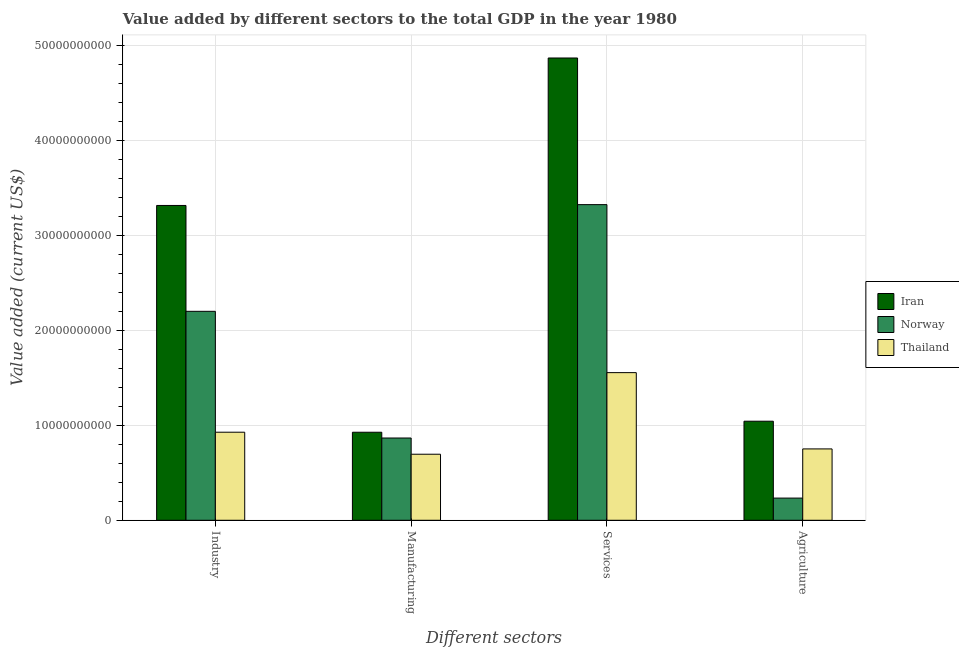How many different coloured bars are there?
Provide a succinct answer. 3. How many groups of bars are there?
Provide a succinct answer. 4. How many bars are there on the 2nd tick from the left?
Offer a very short reply. 3. How many bars are there on the 1st tick from the right?
Your answer should be compact. 3. What is the label of the 1st group of bars from the left?
Your response must be concise. Industry. What is the value added by agricultural sector in Iran?
Make the answer very short. 1.04e+1. Across all countries, what is the maximum value added by agricultural sector?
Provide a succinct answer. 1.04e+1. Across all countries, what is the minimum value added by industrial sector?
Keep it short and to the point. 9.28e+09. In which country was the value added by industrial sector maximum?
Keep it short and to the point. Iran. In which country was the value added by services sector minimum?
Offer a very short reply. Thailand. What is the total value added by services sector in the graph?
Provide a short and direct response. 9.75e+1. What is the difference between the value added by agricultural sector in Thailand and that in Norway?
Your answer should be very brief. 5.18e+09. What is the difference between the value added by agricultural sector in Iran and the value added by manufacturing sector in Thailand?
Give a very brief answer. 3.48e+09. What is the average value added by services sector per country?
Ensure brevity in your answer.  3.25e+1. What is the difference between the value added by agricultural sector and value added by manufacturing sector in Norway?
Offer a very short reply. -6.33e+09. In how many countries, is the value added by services sector greater than 14000000000 US$?
Ensure brevity in your answer.  3. What is the ratio of the value added by agricultural sector in Norway to that in Iran?
Your answer should be very brief. 0.22. Is the difference between the value added by services sector in Iran and Norway greater than the difference between the value added by industrial sector in Iran and Norway?
Offer a terse response. Yes. What is the difference between the highest and the second highest value added by industrial sector?
Provide a short and direct response. 1.12e+1. What is the difference between the highest and the lowest value added by agricultural sector?
Your response must be concise. 8.10e+09. Is the sum of the value added by agricultural sector in Thailand and Iran greater than the maximum value added by industrial sector across all countries?
Your answer should be compact. No. What does the 3rd bar from the left in Manufacturing represents?
Your response must be concise. Thailand. What does the 2nd bar from the right in Industry represents?
Offer a terse response. Norway. Is it the case that in every country, the sum of the value added by industrial sector and value added by manufacturing sector is greater than the value added by services sector?
Your answer should be very brief. No. How many bars are there?
Provide a succinct answer. 12. Are the values on the major ticks of Y-axis written in scientific E-notation?
Provide a short and direct response. No. Does the graph contain any zero values?
Ensure brevity in your answer.  No. Does the graph contain grids?
Keep it short and to the point. Yes. How many legend labels are there?
Your response must be concise. 3. What is the title of the graph?
Your answer should be compact. Value added by different sectors to the total GDP in the year 1980. Does "Bolivia" appear as one of the legend labels in the graph?
Your answer should be very brief. No. What is the label or title of the X-axis?
Make the answer very short. Different sectors. What is the label or title of the Y-axis?
Offer a terse response. Value added (current US$). What is the Value added (current US$) in Iran in Industry?
Your answer should be compact. 3.32e+1. What is the Value added (current US$) of Norway in Industry?
Your answer should be compact. 2.20e+1. What is the Value added (current US$) in Thailand in Industry?
Provide a succinct answer. 9.28e+09. What is the Value added (current US$) of Iran in Manufacturing?
Give a very brief answer. 9.27e+09. What is the Value added (current US$) in Norway in Manufacturing?
Offer a terse response. 8.67e+09. What is the Value added (current US$) of Thailand in Manufacturing?
Provide a short and direct response. 6.96e+09. What is the Value added (current US$) in Iran in Services?
Provide a short and direct response. 4.87e+1. What is the Value added (current US$) in Norway in Services?
Offer a terse response. 3.33e+1. What is the Value added (current US$) of Thailand in Services?
Your response must be concise. 1.56e+1. What is the Value added (current US$) in Iran in Agriculture?
Your answer should be very brief. 1.04e+1. What is the Value added (current US$) of Norway in Agriculture?
Offer a terse response. 2.34e+09. What is the Value added (current US$) in Thailand in Agriculture?
Keep it short and to the point. 7.52e+09. Across all Different sectors, what is the maximum Value added (current US$) of Iran?
Give a very brief answer. 4.87e+1. Across all Different sectors, what is the maximum Value added (current US$) of Norway?
Keep it short and to the point. 3.33e+1. Across all Different sectors, what is the maximum Value added (current US$) in Thailand?
Provide a succinct answer. 1.56e+1. Across all Different sectors, what is the minimum Value added (current US$) in Iran?
Make the answer very short. 9.27e+09. Across all Different sectors, what is the minimum Value added (current US$) in Norway?
Your answer should be very brief. 2.34e+09. Across all Different sectors, what is the minimum Value added (current US$) of Thailand?
Make the answer very short. 6.96e+09. What is the total Value added (current US$) in Iran in the graph?
Give a very brief answer. 1.02e+11. What is the total Value added (current US$) in Norway in the graph?
Your response must be concise. 6.63e+1. What is the total Value added (current US$) of Thailand in the graph?
Provide a short and direct response. 3.93e+1. What is the difference between the Value added (current US$) of Iran in Industry and that in Manufacturing?
Keep it short and to the point. 2.39e+1. What is the difference between the Value added (current US$) in Norway in Industry and that in Manufacturing?
Ensure brevity in your answer.  1.33e+1. What is the difference between the Value added (current US$) of Thailand in Industry and that in Manufacturing?
Ensure brevity in your answer.  2.32e+09. What is the difference between the Value added (current US$) of Iran in Industry and that in Services?
Ensure brevity in your answer.  -1.55e+1. What is the difference between the Value added (current US$) of Norway in Industry and that in Services?
Ensure brevity in your answer.  -1.12e+1. What is the difference between the Value added (current US$) in Thailand in Industry and that in Services?
Make the answer very short. -6.28e+09. What is the difference between the Value added (current US$) in Iran in Industry and that in Agriculture?
Your response must be concise. 2.27e+1. What is the difference between the Value added (current US$) in Norway in Industry and that in Agriculture?
Keep it short and to the point. 1.97e+1. What is the difference between the Value added (current US$) of Thailand in Industry and that in Agriculture?
Keep it short and to the point. 1.76e+09. What is the difference between the Value added (current US$) in Iran in Manufacturing and that in Services?
Ensure brevity in your answer.  -3.94e+1. What is the difference between the Value added (current US$) of Norway in Manufacturing and that in Services?
Provide a short and direct response. -2.46e+1. What is the difference between the Value added (current US$) of Thailand in Manufacturing and that in Services?
Your response must be concise. -8.60e+09. What is the difference between the Value added (current US$) of Iran in Manufacturing and that in Agriculture?
Make the answer very short. -1.16e+09. What is the difference between the Value added (current US$) of Norway in Manufacturing and that in Agriculture?
Your answer should be compact. 6.33e+09. What is the difference between the Value added (current US$) of Thailand in Manufacturing and that in Agriculture?
Your answer should be very brief. -5.59e+08. What is the difference between the Value added (current US$) of Iran in Services and that in Agriculture?
Your response must be concise. 3.83e+1. What is the difference between the Value added (current US$) of Norway in Services and that in Agriculture?
Make the answer very short. 3.09e+1. What is the difference between the Value added (current US$) of Thailand in Services and that in Agriculture?
Offer a terse response. 8.04e+09. What is the difference between the Value added (current US$) in Iran in Industry and the Value added (current US$) in Norway in Manufacturing?
Make the answer very short. 2.45e+1. What is the difference between the Value added (current US$) of Iran in Industry and the Value added (current US$) of Thailand in Manufacturing?
Your answer should be compact. 2.62e+1. What is the difference between the Value added (current US$) of Norway in Industry and the Value added (current US$) of Thailand in Manufacturing?
Provide a short and direct response. 1.51e+1. What is the difference between the Value added (current US$) of Iran in Industry and the Value added (current US$) of Norway in Services?
Keep it short and to the point. -8.79e+07. What is the difference between the Value added (current US$) in Iran in Industry and the Value added (current US$) in Thailand in Services?
Make the answer very short. 1.76e+1. What is the difference between the Value added (current US$) of Norway in Industry and the Value added (current US$) of Thailand in Services?
Offer a terse response. 6.46e+09. What is the difference between the Value added (current US$) in Iran in Industry and the Value added (current US$) in Norway in Agriculture?
Provide a short and direct response. 3.08e+1. What is the difference between the Value added (current US$) of Iran in Industry and the Value added (current US$) of Thailand in Agriculture?
Your response must be concise. 2.57e+1. What is the difference between the Value added (current US$) in Norway in Industry and the Value added (current US$) in Thailand in Agriculture?
Provide a short and direct response. 1.45e+1. What is the difference between the Value added (current US$) in Iran in Manufacturing and the Value added (current US$) in Norway in Services?
Keep it short and to the point. -2.40e+1. What is the difference between the Value added (current US$) in Iran in Manufacturing and the Value added (current US$) in Thailand in Services?
Make the answer very short. -6.28e+09. What is the difference between the Value added (current US$) of Norway in Manufacturing and the Value added (current US$) of Thailand in Services?
Offer a very short reply. -6.89e+09. What is the difference between the Value added (current US$) of Iran in Manufacturing and the Value added (current US$) of Norway in Agriculture?
Your response must be concise. 6.94e+09. What is the difference between the Value added (current US$) of Iran in Manufacturing and the Value added (current US$) of Thailand in Agriculture?
Ensure brevity in your answer.  1.76e+09. What is the difference between the Value added (current US$) in Norway in Manufacturing and the Value added (current US$) in Thailand in Agriculture?
Your answer should be very brief. 1.15e+09. What is the difference between the Value added (current US$) of Iran in Services and the Value added (current US$) of Norway in Agriculture?
Give a very brief answer. 4.64e+1. What is the difference between the Value added (current US$) of Iran in Services and the Value added (current US$) of Thailand in Agriculture?
Give a very brief answer. 4.12e+1. What is the difference between the Value added (current US$) in Norway in Services and the Value added (current US$) in Thailand in Agriculture?
Make the answer very short. 2.57e+1. What is the average Value added (current US$) in Iran per Different sectors?
Offer a very short reply. 2.54e+1. What is the average Value added (current US$) of Norway per Different sectors?
Ensure brevity in your answer.  1.66e+1. What is the average Value added (current US$) in Thailand per Different sectors?
Offer a terse response. 9.83e+09. What is the difference between the Value added (current US$) in Iran and Value added (current US$) in Norway in Industry?
Your answer should be very brief. 1.12e+1. What is the difference between the Value added (current US$) in Iran and Value added (current US$) in Thailand in Industry?
Make the answer very short. 2.39e+1. What is the difference between the Value added (current US$) in Norway and Value added (current US$) in Thailand in Industry?
Provide a short and direct response. 1.27e+1. What is the difference between the Value added (current US$) in Iran and Value added (current US$) in Norway in Manufacturing?
Make the answer very short. 6.06e+08. What is the difference between the Value added (current US$) of Iran and Value added (current US$) of Thailand in Manufacturing?
Keep it short and to the point. 2.32e+09. What is the difference between the Value added (current US$) of Norway and Value added (current US$) of Thailand in Manufacturing?
Your response must be concise. 1.71e+09. What is the difference between the Value added (current US$) of Iran and Value added (current US$) of Norway in Services?
Offer a terse response. 1.55e+1. What is the difference between the Value added (current US$) of Iran and Value added (current US$) of Thailand in Services?
Offer a terse response. 3.32e+1. What is the difference between the Value added (current US$) of Norway and Value added (current US$) of Thailand in Services?
Provide a succinct answer. 1.77e+1. What is the difference between the Value added (current US$) in Iran and Value added (current US$) in Norway in Agriculture?
Offer a terse response. 8.10e+09. What is the difference between the Value added (current US$) in Iran and Value added (current US$) in Thailand in Agriculture?
Provide a short and direct response. 2.92e+09. What is the difference between the Value added (current US$) in Norway and Value added (current US$) in Thailand in Agriculture?
Keep it short and to the point. -5.18e+09. What is the ratio of the Value added (current US$) of Iran in Industry to that in Manufacturing?
Your answer should be very brief. 3.58. What is the ratio of the Value added (current US$) of Norway in Industry to that in Manufacturing?
Offer a very short reply. 2.54. What is the ratio of the Value added (current US$) in Thailand in Industry to that in Manufacturing?
Provide a succinct answer. 1.33. What is the ratio of the Value added (current US$) in Iran in Industry to that in Services?
Keep it short and to the point. 0.68. What is the ratio of the Value added (current US$) in Norway in Industry to that in Services?
Keep it short and to the point. 0.66. What is the ratio of the Value added (current US$) of Thailand in Industry to that in Services?
Your answer should be very brief. 0.6. What is the ratio of the Value added (current US$) of Iran in Industry to that in Agriculture?
Offer a very short reply. 3.18. What is the ratio of the Value added (current US$) in Norway in Industry to that in Agriculture?
Ensure brevity in your answer.  9.42. What is the ratio of the Value added (current US$) of Thailand in Industry to that in Agriculture?
Offer a very short reply. 1.23. What is the ratio of the Value added (current US$) of Iran in Manufacturing to that in Services?
Ensure brevity in your answer.  0.19. What is the ratio of the Value added (current US$) in Norway in Manufacturing to that in Services?
Ensure brevity in your answer.  0.26. What is the ratio of the Value added (current US$) in Thailand in Manufacturing to that in Services?
Keep it short and to the point. 0.45. What is the ratio of the Value added (current US$) of Iran in Manufacturing to that in Agriculture?
Ensure brevity in your answer.  0.89. What is the ratio of the Value added (current US$) in Norway in Manufacturing to that in Agriculture?
Keep it short and to the point. 3.71. What is the ratio of the Value added (current US$) of Thailand in Manufacturing to that in Agriculture?
Offer a very short reply. 0.93. What is the ratio of the Value added (current US$) in Iran in Services to that in Agriculture?
Ensure brevity in your answer.  4.67. What is the ratio of the Value added (current US$) of Norway in Services to that in Agriculture?
Give a very brief answer. 14.23. What is the ratio of the Value added (current US$) of Thailand in Services to that in Agriculture?
Your answer should be very brief. 2.07. What is the difference between the highest and the second highest Value added (current US$) of Iran?
Keep it short and to the point. 1.55e+1. What is the difference between the highest and the second highest Value added (current US$) of Norway?
Offer a very short reply. 1.12e+1. What is the difference between the highest and the second highest Value added (current US$) of Thailand?
Provide a short and direct response. 6.28e+09. What is the difference between the highest and the lowest Value added (current US$) of Iran?
Your response must be concise. 3.94e+1. What is the difference between the highest and the lowest Value added (current US$) of Norway?
Ensure brevity in your answer.  3.09e+1. What is the difference between the highest and the lowest Value added (current US$) of Thailand?
Your answer should be very brief. 8.60e+09. 